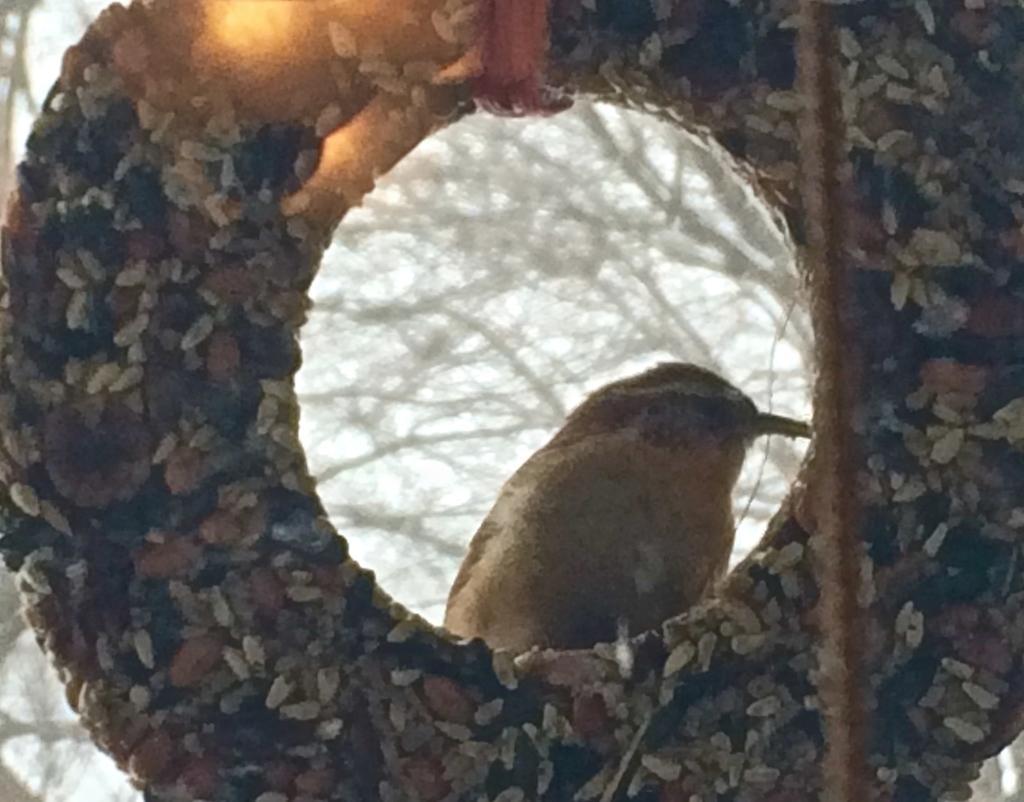Could you give a brief overview of what you see in this image? In this picture we can see a circular object. Through this circular object we can see a bird and a few trees in the background. 